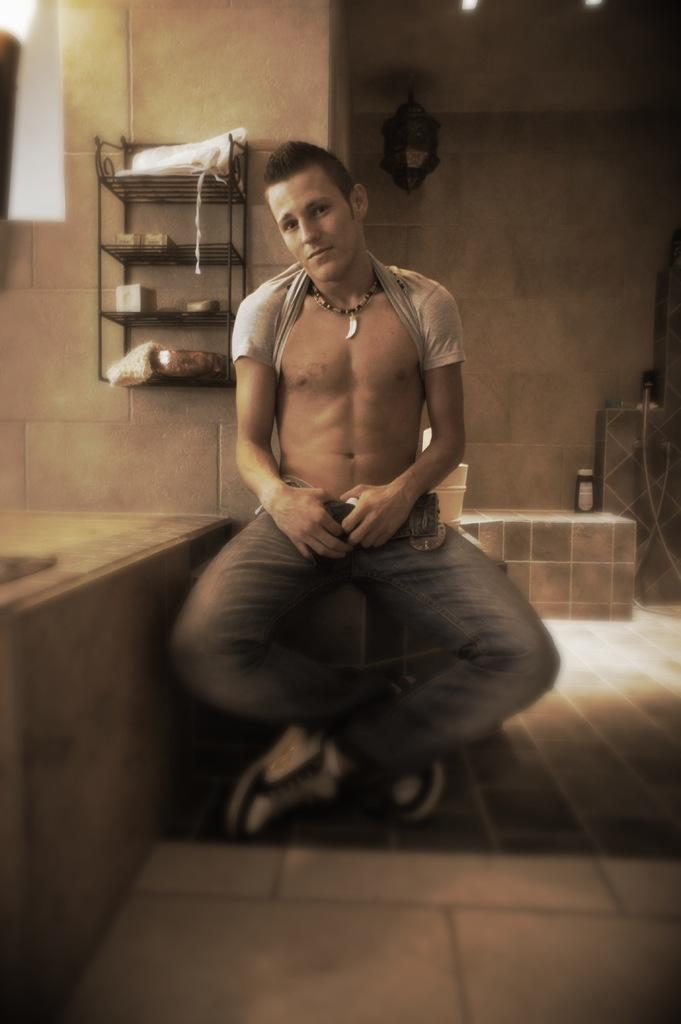What is the man in the image doing? The man is sitting in the image. What can be found inside the rock in the image? There are objects in the rock in the image. What else can be seen in the image besides the man and the rock? There are items in the image. What is visible in the background of the image? There is a wall in the background of the image. Is the beggar using the umbrella to protect himself from the rain in the image? There is no beggar or umbrella present in the image. 